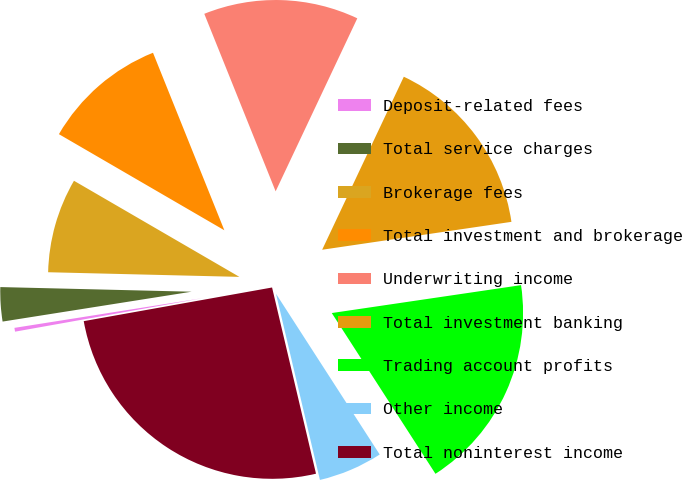Convert chart. <chart><loc_0><loc_0><loc_500><loc_500><pie_chart><fcel>Deposit-related fees<fcel>Total service charges<fcel>Brokerage fees<fcel>Total investment and brokerage<fcel>Underwriting income<fcel>Total investment banking<fcel>Trading account profits<fcel>Other income<fcel>Total noninterest income<nl><fcel>0.32%<fcel>2.88%<fcel>7.99%<fcel>10.54%<fcel>13.1%<fcel>15.65%<fcel>18.21%<fcel>5.43%<fcel>25.87%<nl></chart> 